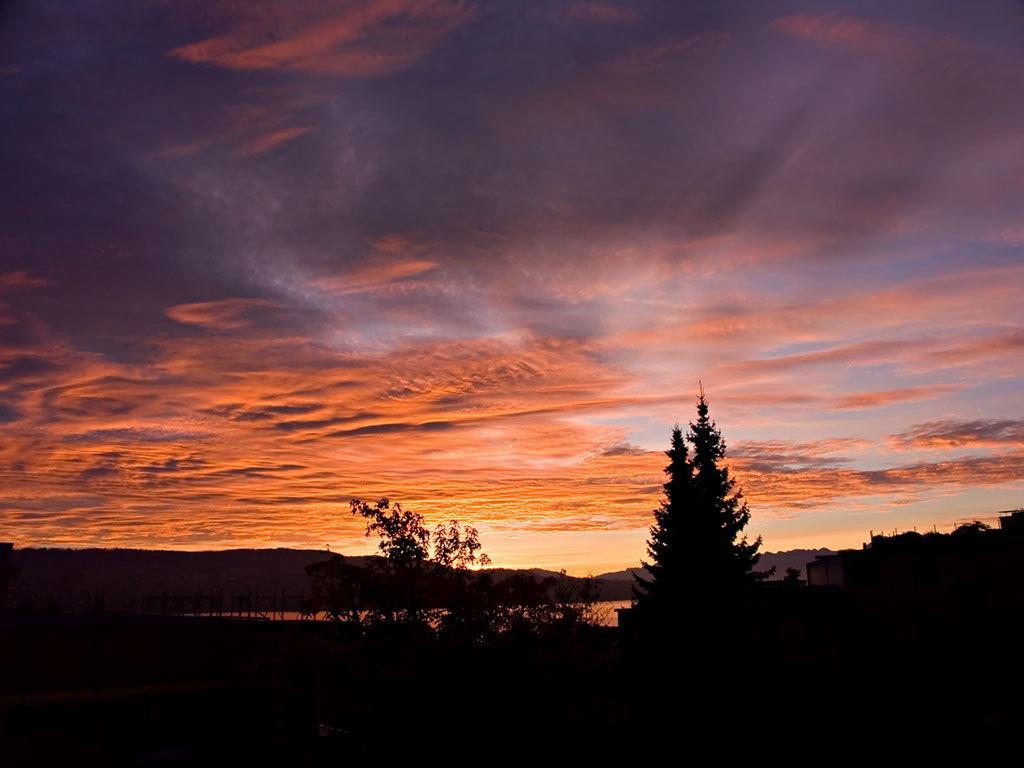How would you summarize this image in a sentence or two? In this picture, it looks like a house and on the left side of the house there are trees and in front of the house there are hills and the sky. 